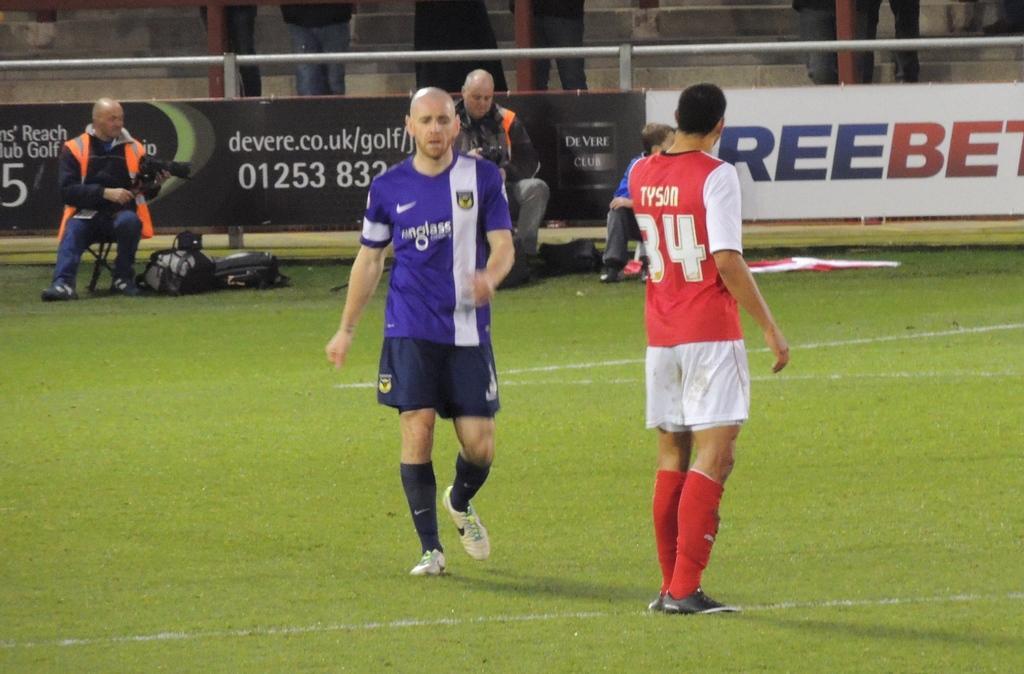In one or two sentences, can you explain what this image depicts? This picture is taken inside the room. In this image, in the middle, we can see two people are walking on the grass. In the background, we can see three people are sitting. In the background, we can see hoardings, metal rod, staircase, a group of people. At the bottom, we can see some bags, cloth and a grass. 